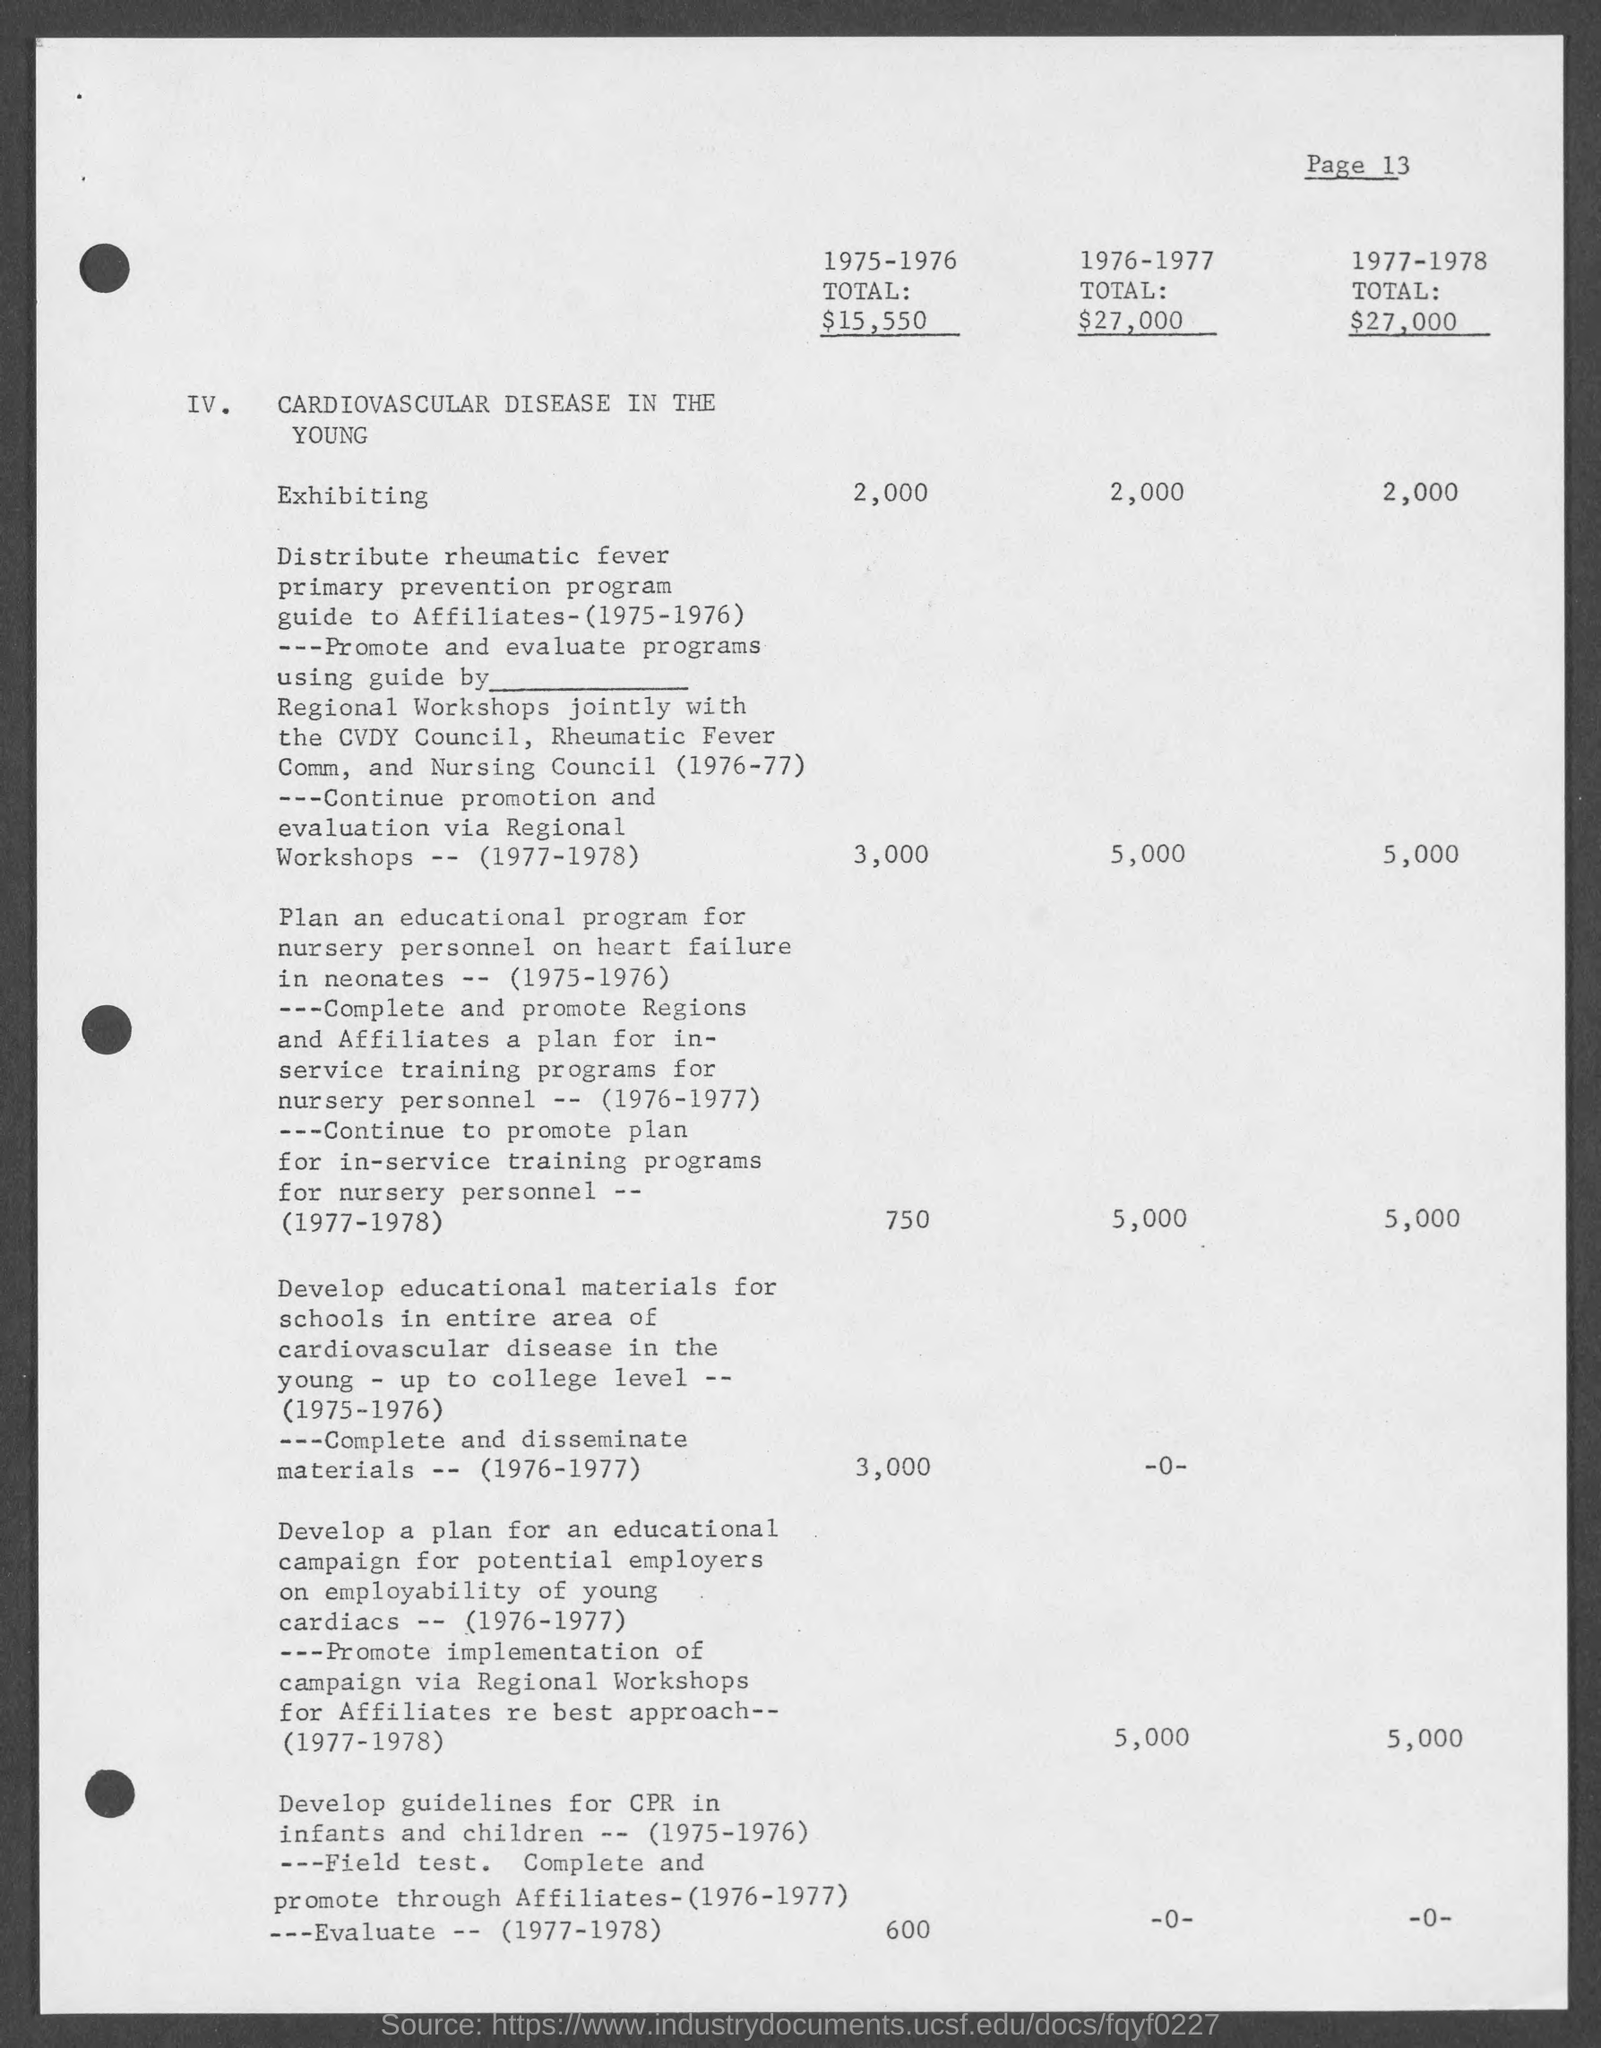Indicate a few pertinent items in this graphic. In the years 1975 and 1976, the total was 15,550. 